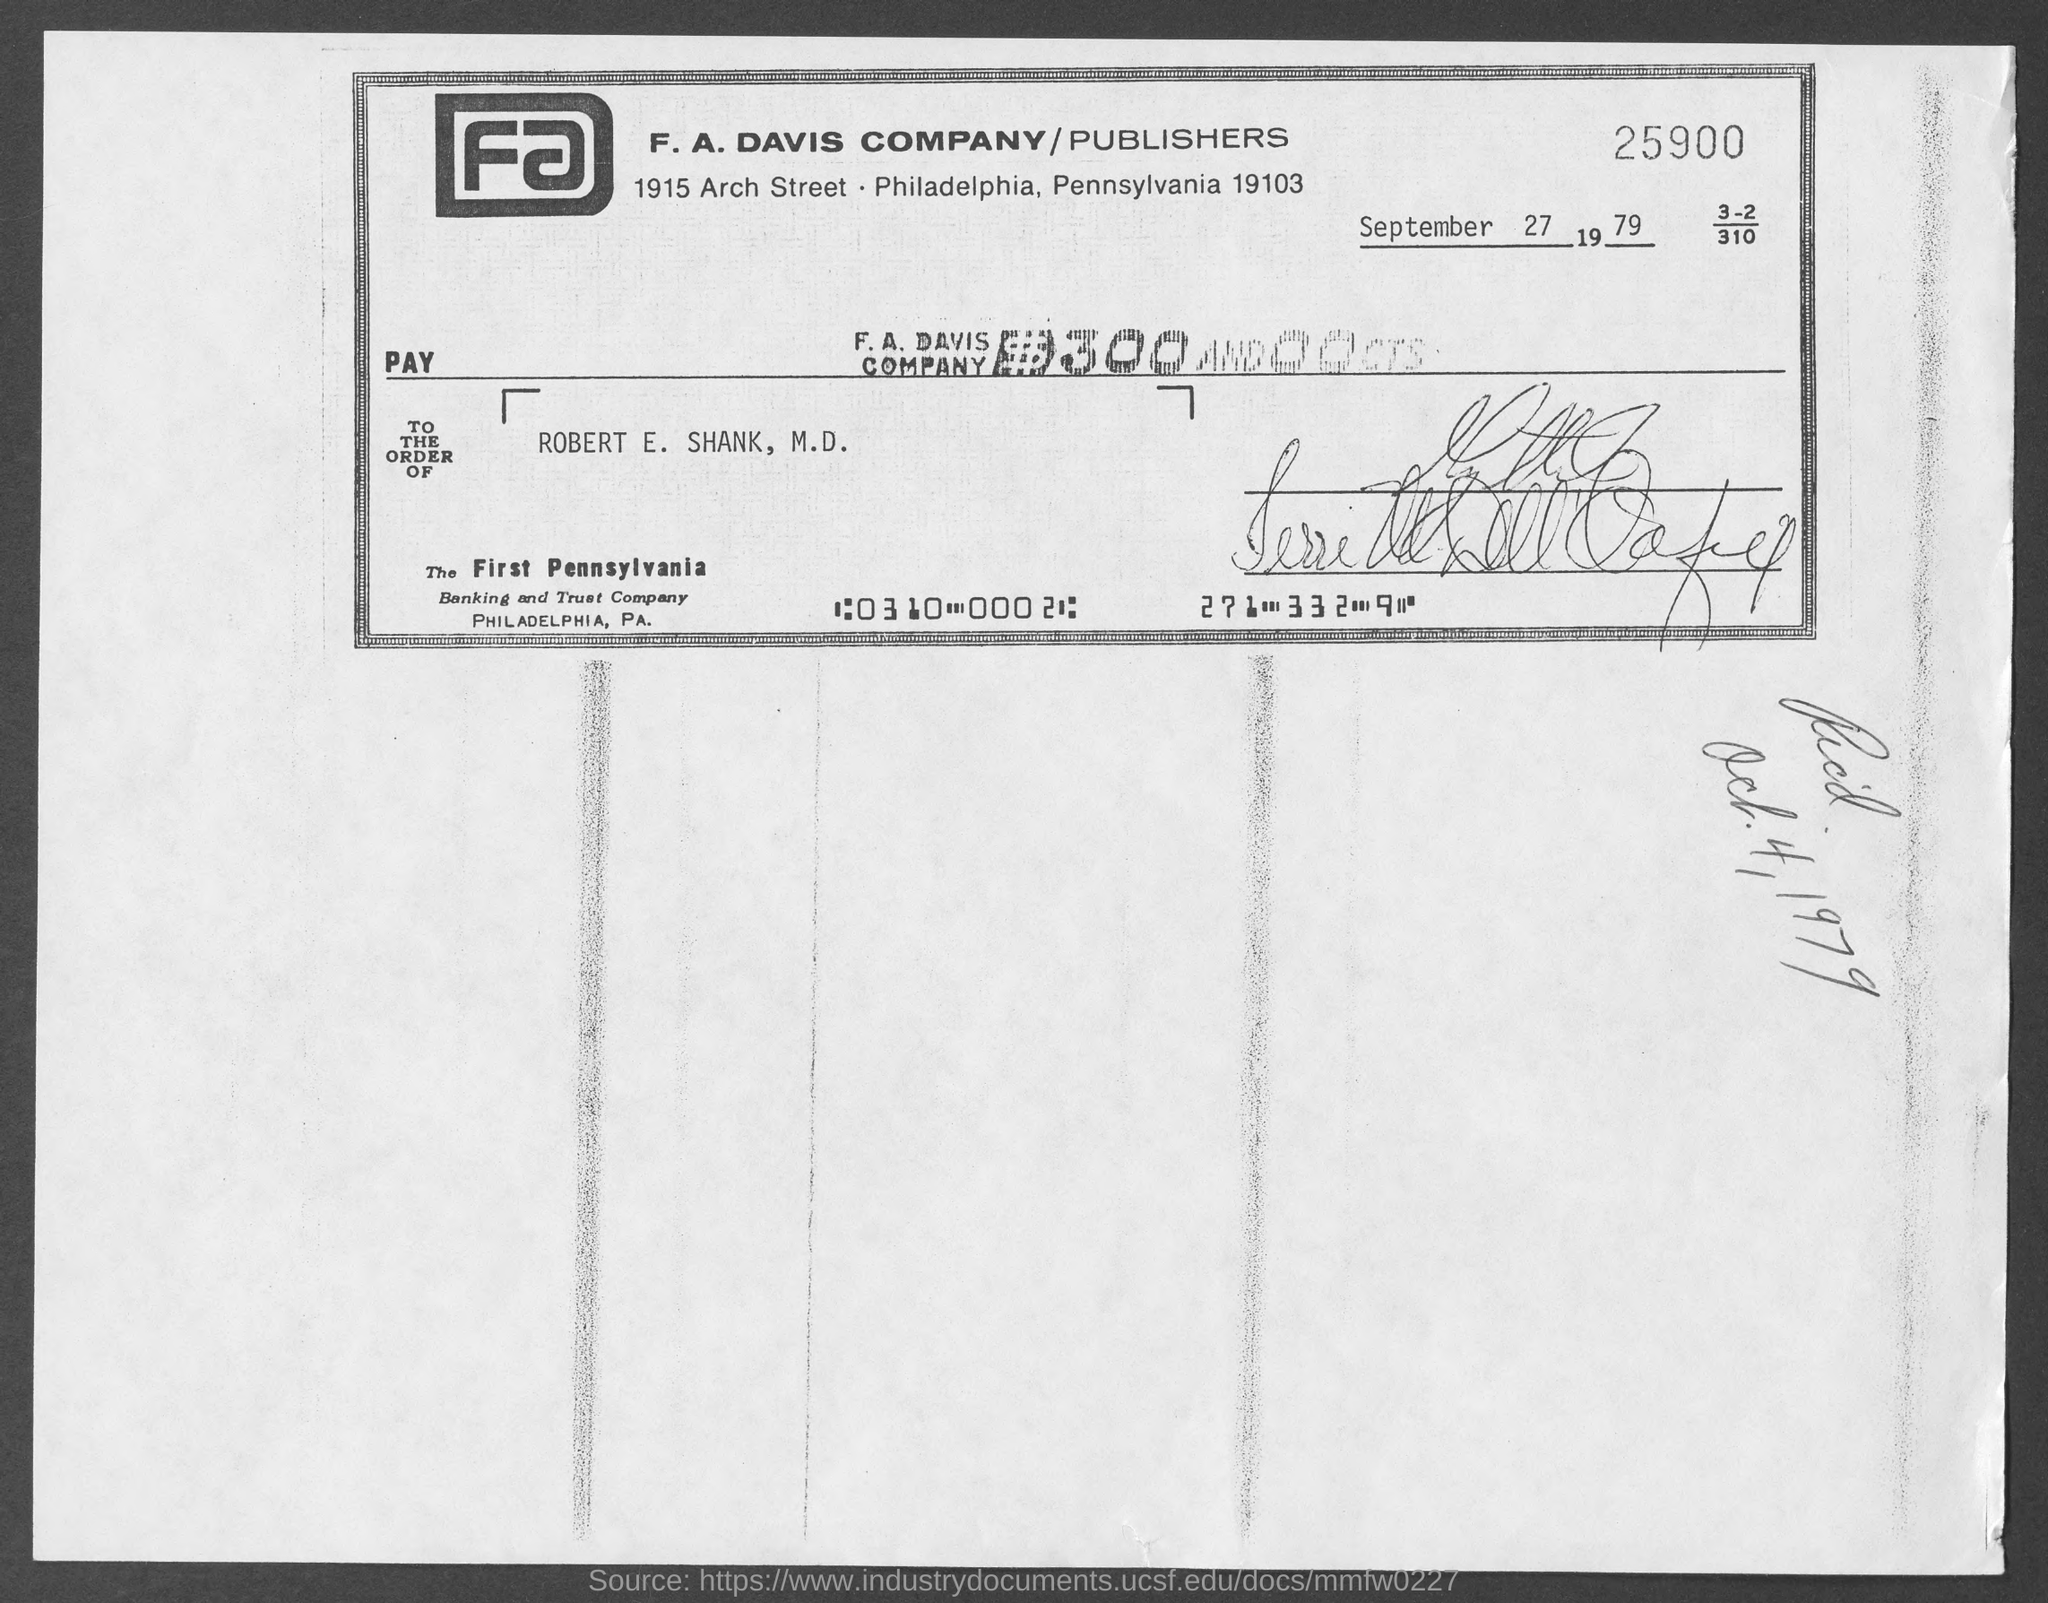Indicate a few pertinent items in this graphic. The document was dated September 27, 1979. The document is addressed to the order of Robert E. Shank, M.D. 